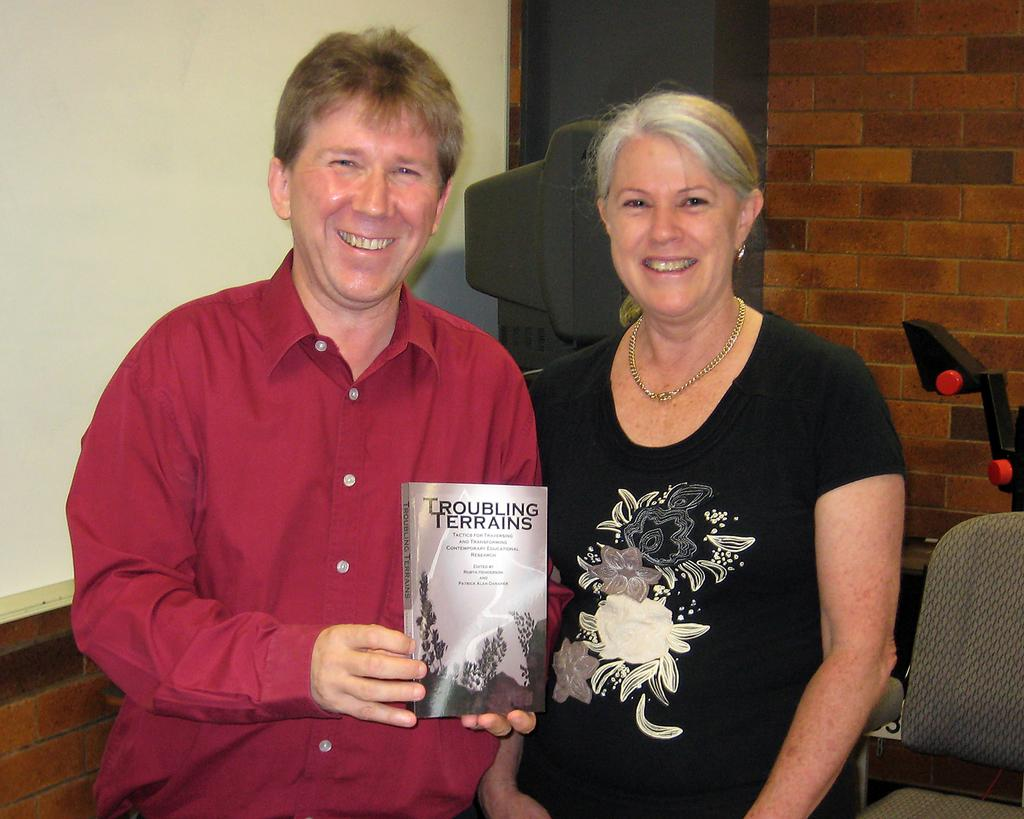<image>
Summarize the visual content of the image. A man holds a copy of Troubling Terrains as he poses for a photo with a woman. 